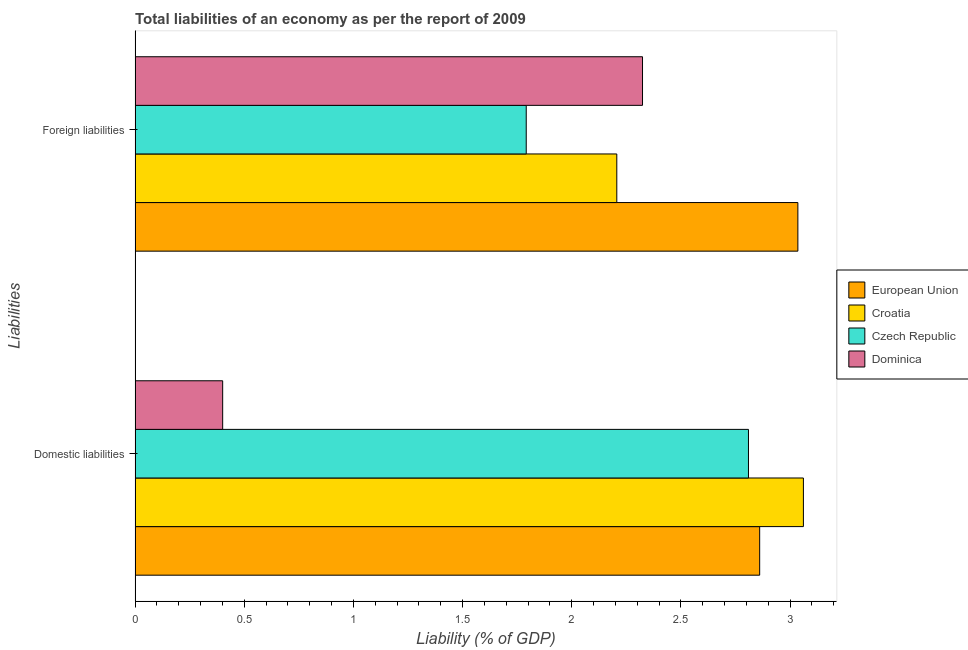How many groups of bars are there?
Make the answer very short. 2. Are the number of bars per tick equal to the number of legend labels?
Keep it short and to the point. Yes. Are the number of bars on each tick of the Y-axis equal?
Your answer should be very brief. Yes. What is the label of the 2nd group of bars from the top?
Provide a short and direct response. Domestic liabilities. What is the incurrence of domestic liabilities in European Union?
Your answer should be very brief. 2.86. Across all countries, what is the maximum incurrence of domestic liabilities?
Offer a terse response. 3.06. Across all countries, what is the minimum incurrence of domestic liabilities?
Provide a short and direct response. 0.4. In which country was the incurrence of domestic liabilities maximum?
Offer a terse response. Croatia. In which country was the incurrence of foreign liabilities minimum?
Make the answer very short. Czech Republic. What is the total incurrence of foreign liabilities in the graph?
Your answer should be very brief. 9.36. What is the difference between the incurrence of foreign liabilities in European Union and that in Croatia?
Your answer should be very brief. 0.83. What is the difference between the incurrence of domestic liabilities in Dominica and the incurrence of foreign liabilities in Croatia?
Keep it short and to the point. -1.8. What is the average incurrence of foreign liabilities per country?
Ensure brevity in your answer.  2.34. What is the difference between the incurrence of foreign liabilities and incurrence of domestic liabilities in Dominica?
Provide a short and direct response. 1.92. What is the ratio of the incurrence of foreign liabilities in European Union to that in Croatia?
Your answer should be very brief. 1.38. Is the incurrence of domestic liabilities in Czech Republic less than that in Dominica?
Provide a short and direct response. No. In how many countries, is the incurrence of foreign liabilities greater than the average incurrence of foreign liabilities taken over all countries?
Keep it short and to the point. 1. What does the 2nd bar from the top in Foreign liabilities represents?
Offer a very short reply. Czech Republic. What does the 1st bar from the bottom in Domestic liabilities represents?
Keep it short and to the point. European Union. Are all the bars in the graph horizontal?
Provide a succinct answer. Yes. What is the difference between two consecutive major ticks on the X-axis?
Your answer should be compact. 0.5. Does the graph contain any zero values?
Provide a short and direct response. No. Does the graph contain grids?
Offer a terse response. No. How many legend labels are there?
Keep it short and to the point. 4. What is the title of the graph?
Offer a terse response. Total liabilities of an economy as per the report of 2009. What is the label or title of the X-axis?
Your answer should be very brief. Liability (% of GDP). What is the label or title of the Y-axis?
Offer a very short reply. Liabilities. What is the Liability (% of GDP) of European Union in Domestic liabilities?
Make the answer very short. 2.86. What is the Liability (% of GDP) of Croatia in Domestic liabilities?
Make the answer very short. 3.06. What is the Liability (% of GDP) of Czech Republic in Domestic liabilities?
Offer a terse response. 2.81. What is the Liability (% of GDP) of Dominica in Domestic liabilities?
Offer a terse response. 0.4. What is the Liability (% of GDP) of European Union in Foreign liabilities?
Your answer should be very brief. 3.04. What is the Liability (% of GDP) in Croatia in Foreign liabilities?
Ensure brevity in your answer.  2.21. What is the Liability (% of GDP) of Czech Republic in Foreign liabilities?
Ensure brevity in your answer.  1.79. What is the Liability (% of GDP) in Dominica in Foreign liabilities?
Your response must be concise. 2.32. Across all Liabilities, what is the maximum Liability (% of GDP) of European Union?
Give a very brief answer. 3.04. Across all Liabilities, what is the maximum Liability (% of GDP) of Croatia?
Provide a succinct answer. 3.06. Across all Liabilities, what is the maximum Liability (% of GDP) of Czech Republic?
Give a very brief answer. 2.81. Across all Liabilities, what is the maximum Liability (% of GDP) of Dominica?
Your answer should be compact. 2.32. Across all Liabilities, what is the minimum Liability (% of GDP) of European Union?
Give a very brief answer. 2.86. Across all Liabilities, what is the minimum Liability (% of GDP) in Croatia?
Offer a very short reply. 2.21. Across all Liabilities, what is the minimum Liability (% of GDP) in Czech Republic?
Give a very brief answer. 1.79. Across all Liabilities, what is the minimum Liability (% of GDP) in Dominica?
Keep it short and to the point. 0.4. What is the total Liability (% of GDP) of European Union in the graph?
Provide a succinct answer. 5.9. What is the total Liability (% of GDP) of Croatia in the graph?
Offer a terse response. 5.27. What is the total Liability (% of GDP) in Czech Republic in the graph?
Provide a succinct answer. 4.6. What is the total Liability (% of GDP) in Dominica in the graph?
Provide a succinct answer. 2.73. What is the difference between the Liability (% of GDP) in European Union in Domestic liabilities and that in Foreign liabilities?
Offer a very short reply. -0.17. What is the difference between the Liability (% of GDP) in Croatia in Domestic liabilities and that in Foreign liabilities?
Your answer should be very brief. 0.85. What is the difference between the Liability (% of GDP) of Czech Republic in Domestic liabilities and that in Foreign liabilities?
Offer a very short reply. 1.02. What is the difference between the Liability (% of GDP) in Dominica in Domestic liabilities and that in Foreign liabilities?
Provide a succinct answer. -1.92. What is the difference between the Liability (% of GDP) of European Union in Domestic liabilities and the Liability (% of GDP) of Croatia in Foreign liabilities?
Your answer should be very brief. 0.65. What is the difference between the Liability (% of GDP) in European Union in Domestic liabilities and the Liability (% of GDP) in Czech Republic in Foreign liabilities?
Offer a terse response. 1.07. What is the difference between the Liability (% of GDP) of European Union in Domestic liabilities and the Liability (% of GDP) of Dominica in Foreign liabilities?
Make the answer very short. 0.54. What is the difference between the Liability (% of GDP) of Croatia in Domestic liabilities and the Liability (% of GDP) of Czech Republic in Foreign liabilities?
Offer a very short reply. 1.27. What is the difference between the Liability (% of GDP) in Croatia in Domestic liabilities and the Liability (% of GDP) in Dominica in Foreign liabilities?
Ensure brevity in your answer.  0.74. What is the difference between the Liability (% of GDP) of Czech Republic in Domestic liabilities and the Liability (% of GDP) of Dominica in Foreign liabilities?
Ensure brevity in your answer.  0.49. What is the average Liability (% of GDP) of European Union per Liabilities?
Make the answer very short. 2.95. What is the average Liability (% of GDP) of Croatia per Liabilities?
Provide a short and direct response. 2.63. What is the average Liability (% of GDP) in Czech Republic per Liabilities?
Give a very brief answer. 2.3. What is the average Liability (% of GDP) of Dominica per Liabilities?
Provide a short and direct response. 1.36. What is the difference between the Liability (% of GDP) in European Union and Liability (% of GDP) in Croatia in Domestic liabilities?
Your answer should be compact. -0.2. What is the difference between the Liability (% of GDP) of European Union and Liability (% of GDP) of Czech Republic in Domestic liabilities?
Your answer should be very brief. 0.05. What is the difference between the Liability (% of GDP) of European Union and Liability (% of GDP) of Dominica in Domestic liabilities?
Keep it short and to the point. 2.46. What is the difference between the Liability (% of GDP) in Croatia and Liability (% of GDP) in Czech Republic in Domestic liabilities?
Offer a very short reply. 0.25. What is the difference between the Liability (% of GDP) in Croatia and Liability (% of GDP) in Dominica in Domestic liabilities?
Offer a terse response. 2.66. What is the difference between the Liability (% of GDP) in Czech Republic and Liability (% of GDP) in Dominica in Domestic liabilities?
Keep it short and to the point. 2.41. What is the difference between the Liability (% of GDP) of European Union and Liability (% of GDP) of Croatia in Foreign liabilities?
Your response must be concise. 0.83. What is the difference between the Liability (% of GDP) of European Union and Liability (% of GDP) of Czech Republic in Foreign liabilities?
Make the answer very short. 1.24. What is the difference between the Liability (% of GDP) of European Union and Liability (% of GDP) of Dominica in Foreign liabilities?
Offer a very short reply. 0.71. What is the difference between the Liability (% of GDP) of Croatia and Liability (% of GDP) of Czech Republic in Foreign liabilities?
Your answer should be compact. 0.41. What is the difference between the Liability (% of GDP) in Croatia and Liability (% of GDP) in Dominica in Foreign liabilities?
Offer a terse response. -0.12. What is the difference between the Liability (% of GDP) of Czech Republic and Liability (% of GDP) of Dominica in Foreign liabilities?
Make the answer very short. -0.53. What is the ratio of the Liability (% of GDP) in European Union in Domestic liabilities to that in Foreign liabilities?
Ensure brevity in your answer.  0.94. What is the ratio of the Liability (% of GDP) in Croatia in Domestic liabilities to that in Foreign liabilities?
Provide a succinct answer. 1.39. What is the ratio of the Liability (% of GDP) of Czech Republic in Domestic liabilities to that in Foreign liabilities?
Offer a very short reply. 1.57. What is the ratio of the Liability (% of GDP) in Dominica in Domestic liabilities to that in Foreign liabilities?
Give a very brief answer. 0.17. What is the difference between the highest and the second highest Liability (% of GDP) of European Union?
Make the answer very short. 0.17. What is the difference between the highest and the second highest Liability (% of GDP) of Croatia?
Provide a short and direct response. 0.85. What is the difference between the highest and the second highest Liability (% of GDP) in Czech Republic?
Your response must be concise. 1.02. What is the difference between the highest and the second highest Liability (% of GDP) in Dominica?
Your response must be concise. 1.92. What is the difference between the highest and the lowest Liability (% of GDP) in European Union?
Make the answer very short. 0.17. What is the difference between the highest and the lowest Liability (% of GDP) in Croatia?
Your response must be concise. 0.85. What is the difference between the highest and the lowest Liability (% of GDP) of Czech Republic?
Give a very brief answer. 1.02. What is the difference between the highest and the lowest Liability (% of GDP) in Dominica?
Your answer should be very brief. 1.92. 